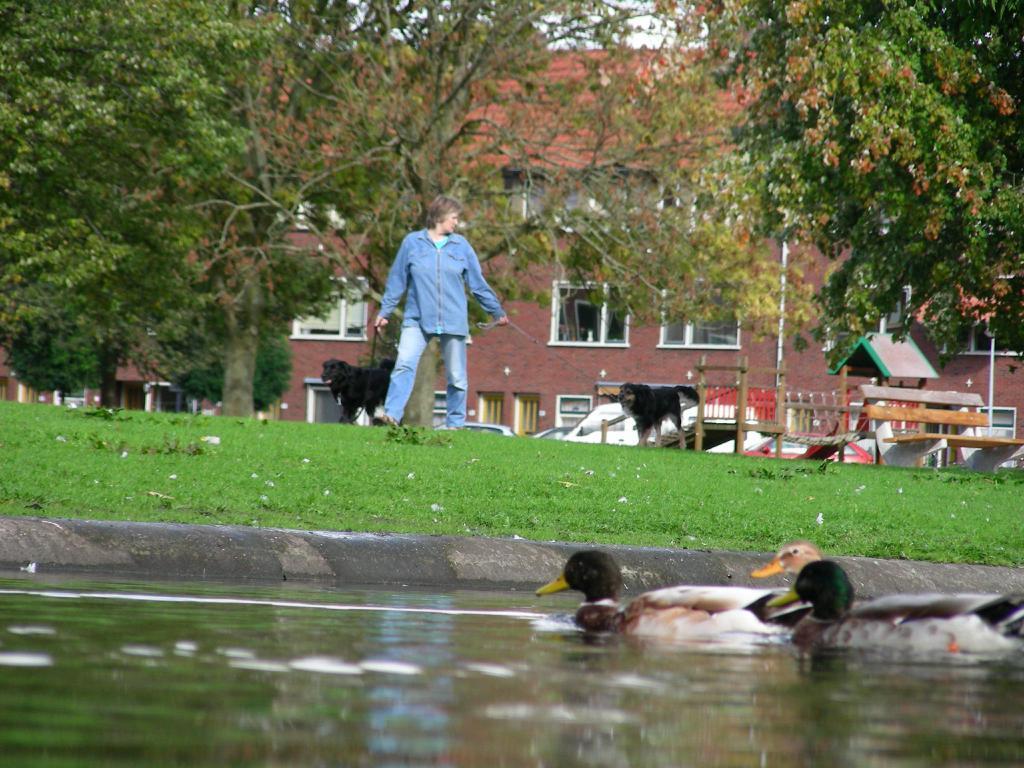In one or two sentences, can you explain what this image depicts? In this image, I can see a person holding two dog belts with dogs and walking on the grass. On the right side of the image, I can see a wooden bench. In the background, there are trees, vehicles and a building with windows. At the bottom of the image, I can see three ducks in the water. 